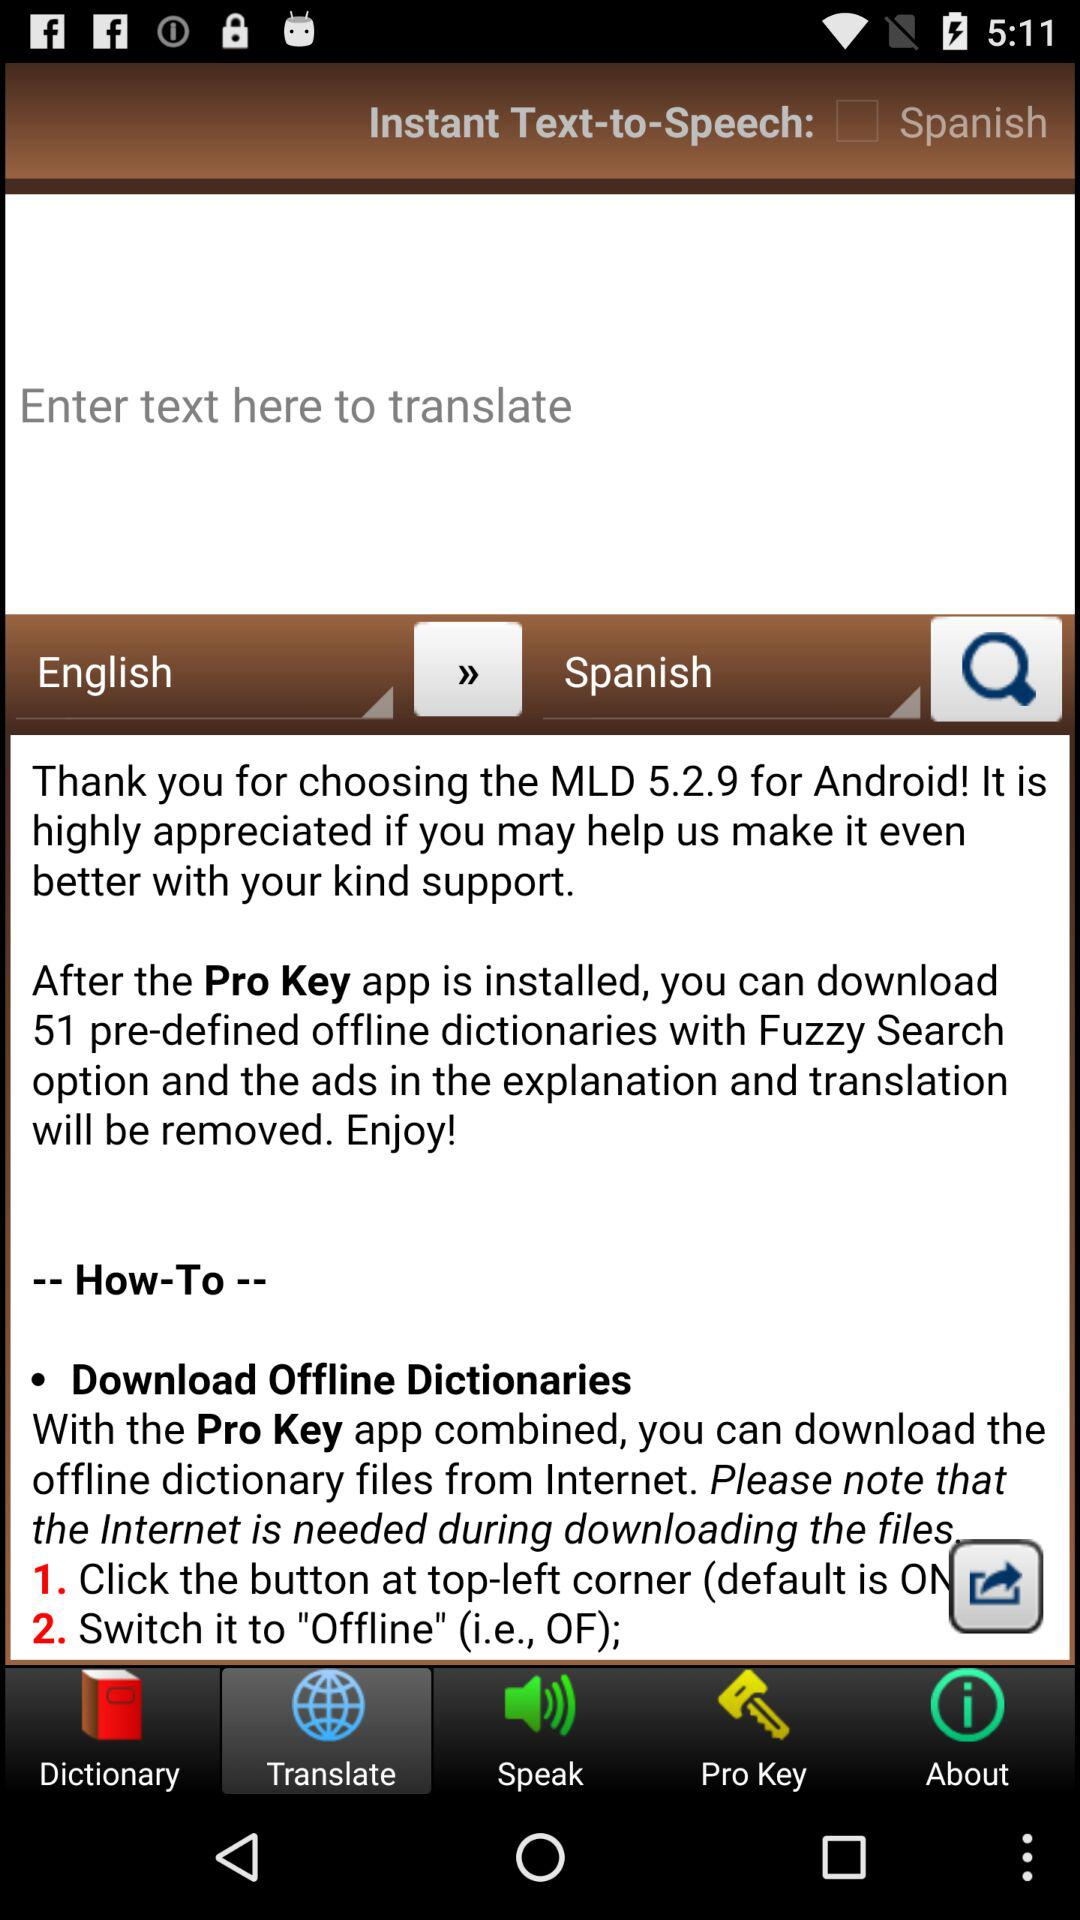What tab is selected? The selected tab is "Translate". 